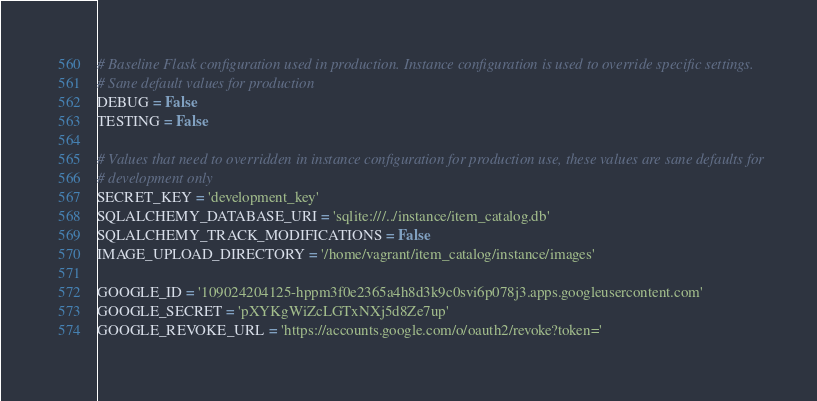Convert code to text. <code><loc_0><loc_0><loc_500><loc_500><_Python_># Baseline Flask configuration used in production. Instance configuration is used to override specific settings.
# Sane default values for production
DEBUG = False
TESTING = False

# Values that need to overridden in instance configuration for production use, these values are sane defaults for
# development only
SECRET_KEY = 'development_key'
SQLALCHEMY_DATABASE_URI = 'sqlite:///../instance/item_catalog.db'
SQLALCHEMY_TRACK_MODIFICATIONS = False
IMAGE_UPLOAD_DIRECTORY = '/home/vagrant/item_catalog/instance/images'

GOOGLE_ID = '109024204125-hppm3f0e2365a4h8d3k9c0svi6p078j3.apps.googleusercontent.com'
GOOGLE_SECRET = 'pXYKgWiZcLGTxNXj5d8Ze7up'
GOOGLE_REVOKE_URL = 'https://accounts.google.com/o/oauth2/revoke?token='
</code> 